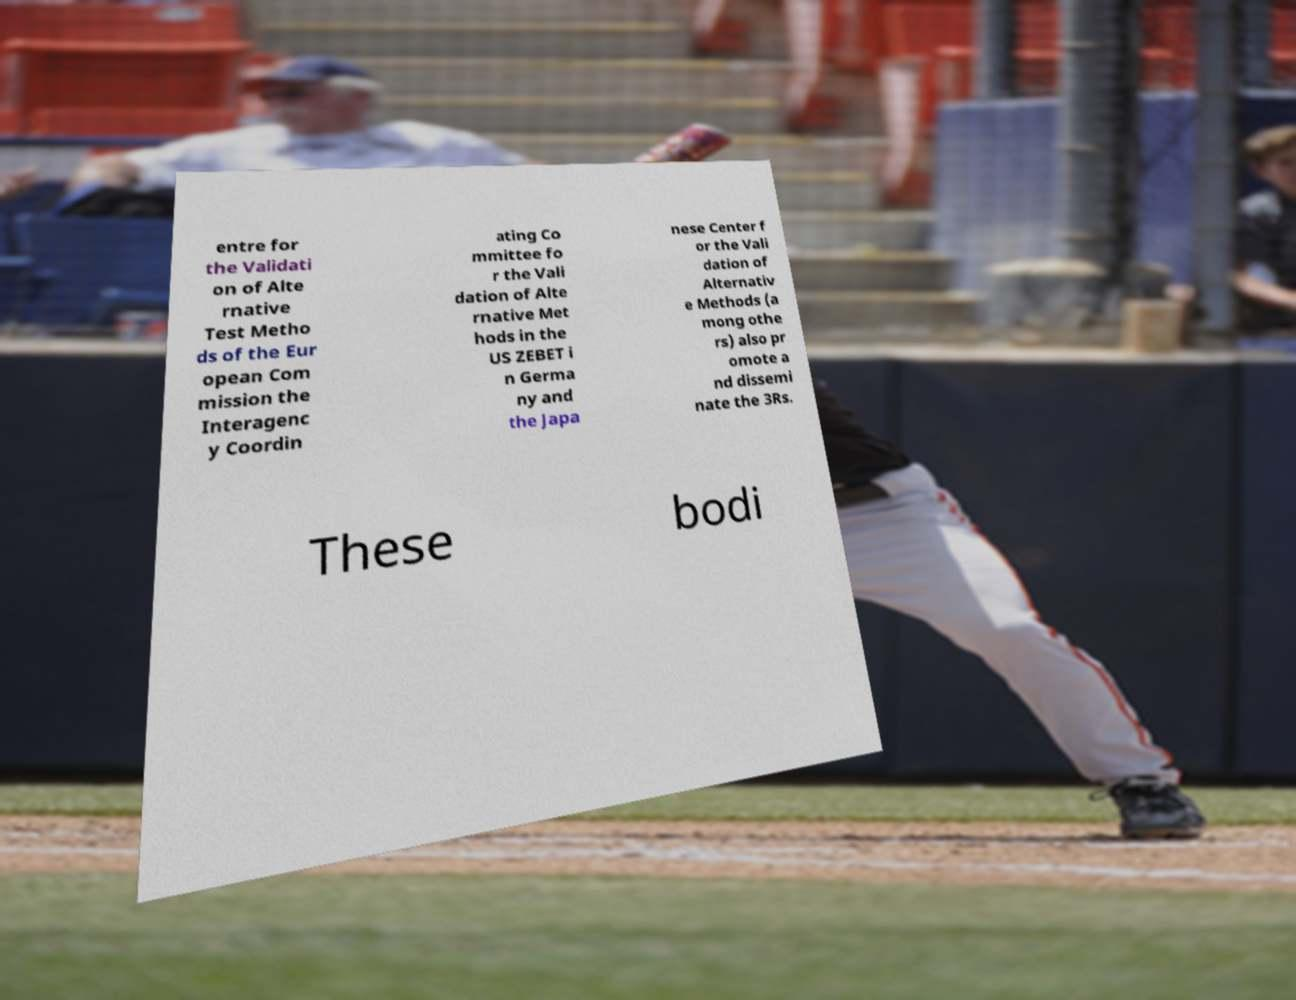Could you assist in decoding the text presented in this image and type it out clearly? entre for the Validati on of Alte rnative Test Metho ds of the Eur opean Com mission the Interagenc y Coordin ating Co mmittee fo r the Vali dation of Alte rnative Met hods in the US ZEBET i n Germa ny and the Japa nese Center f or the Vali dation of Alternativ e Methods (a mong othe rs) also pr omote a nd dissemi nate the 3Rs. These bodi 